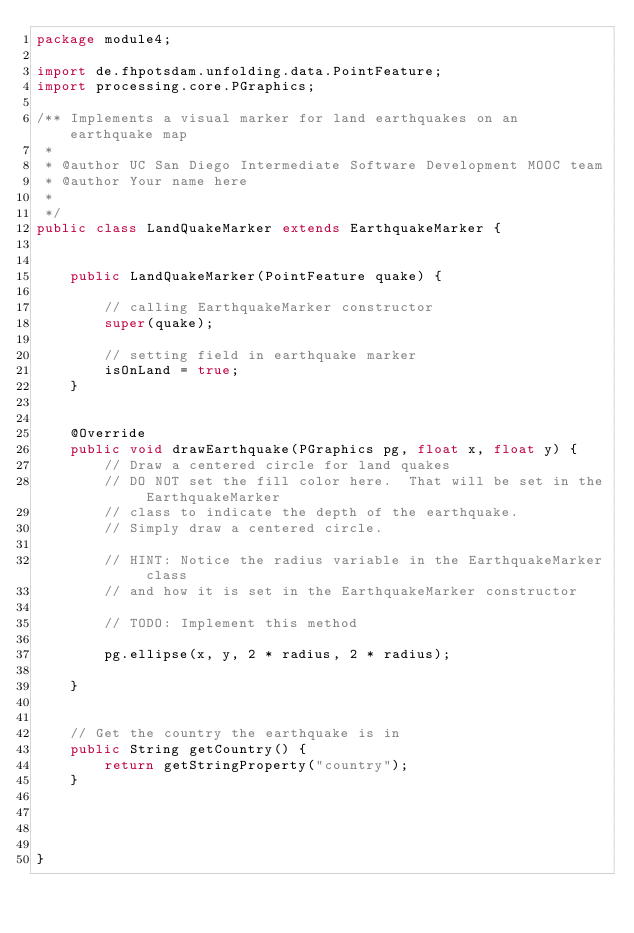Convert code to text. <code><loc_0><loc_0><loc_500><loc_500><_Java_>package module4;

import de.fhpotsdam.unfolding.data.PointFeature;
import processing.core.PGraphics;

/** Implements a visual marker for land earthquakes on an earthquake map
 * 
 * @author UC San Diego Intermediate Software Development MOOC team
 * @author Your name here
 *
 */
public class LandQuakeMarker extends EarthquakeMarker {
	
	
	public LandQuakeMarker(PointFeature quake) {
		
		// calling EarthquakeMarker constructor
		super(quake);
		
		// setting field in earthquake marker
		isOnLand = true;
	}


	@Override
	public void drawEarthquake(PGraphics pg, float x, float y) {
		// Draw a centered circle for land quakes
		// DO NOT set the fill color here.  That will be set in the EarthquakeMarker
		// class to indicate the depth of the earthquake.
		// Simply draw a centered circle.
		
		// HINT: Notice the radius variable in the EarthquakeMarker class
		// and how it is set in the EarthquakeMarker constructor
		
		// TODO: Implement this method
		
		pg.ellipse(x, y, 2 * radius, 2 * radius);
		
	}
	

	// Get the country the earthquake is in
	public String getCountry() {
		return getStringProperty("country");
	}



		
}</code> 